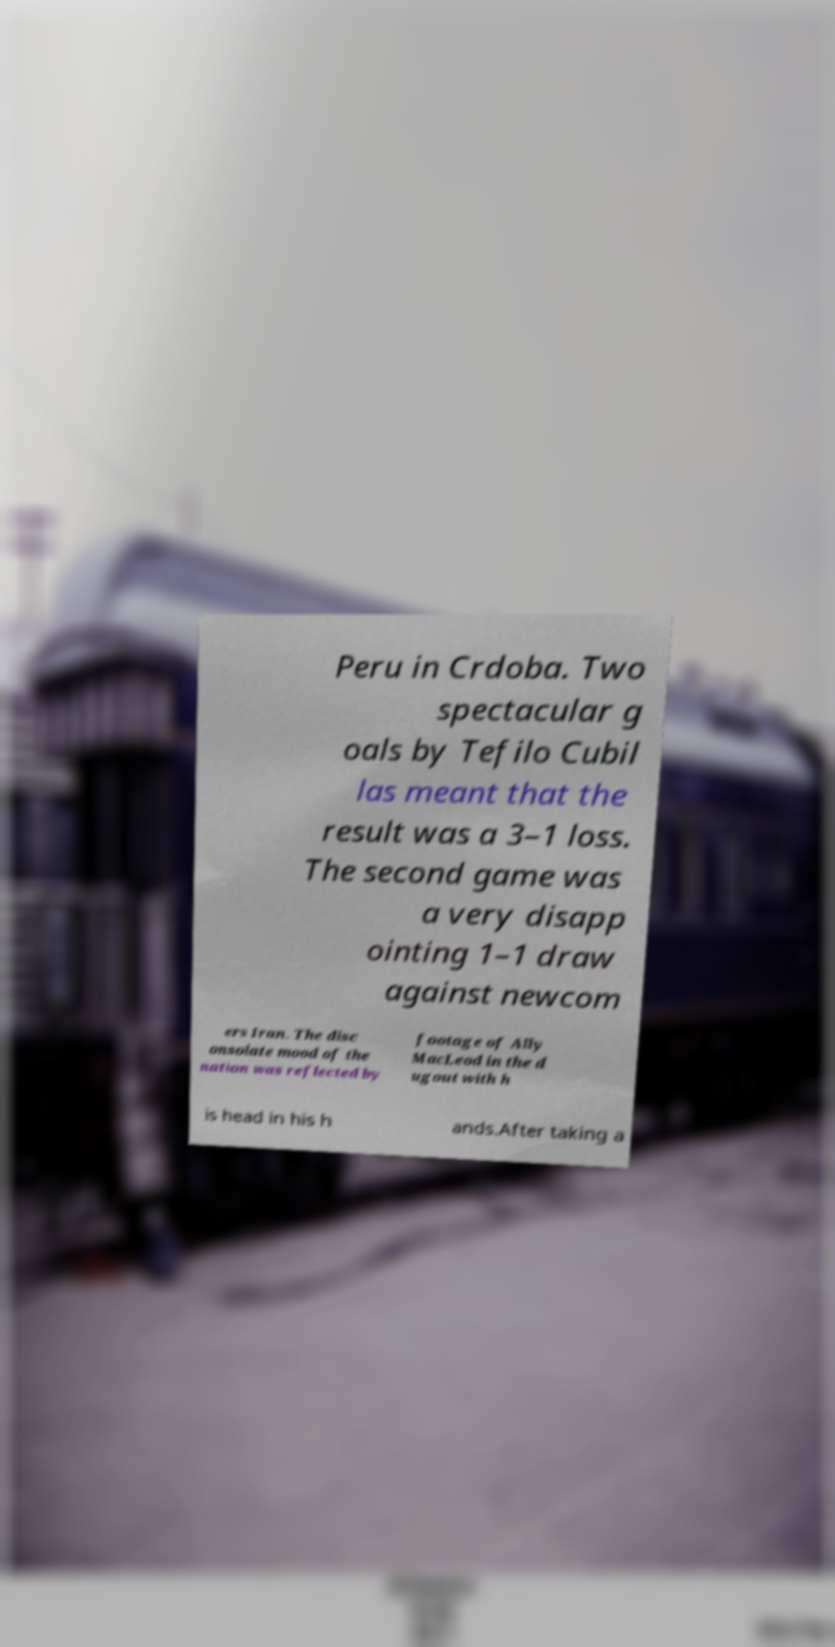Please identify and transcribe the text found in this image. Peru in Crdoba. Two spectacular g oals by Tefilo Cubil las meant that the result was a 3–1 loss. The second game was a very disapp ointing 1–1 draw against newcom ers Iran. The disc onsolate mood of the nation was reflected by footage of Ally MacLeod in the d ugout with h is head in his h ands.After taking a 